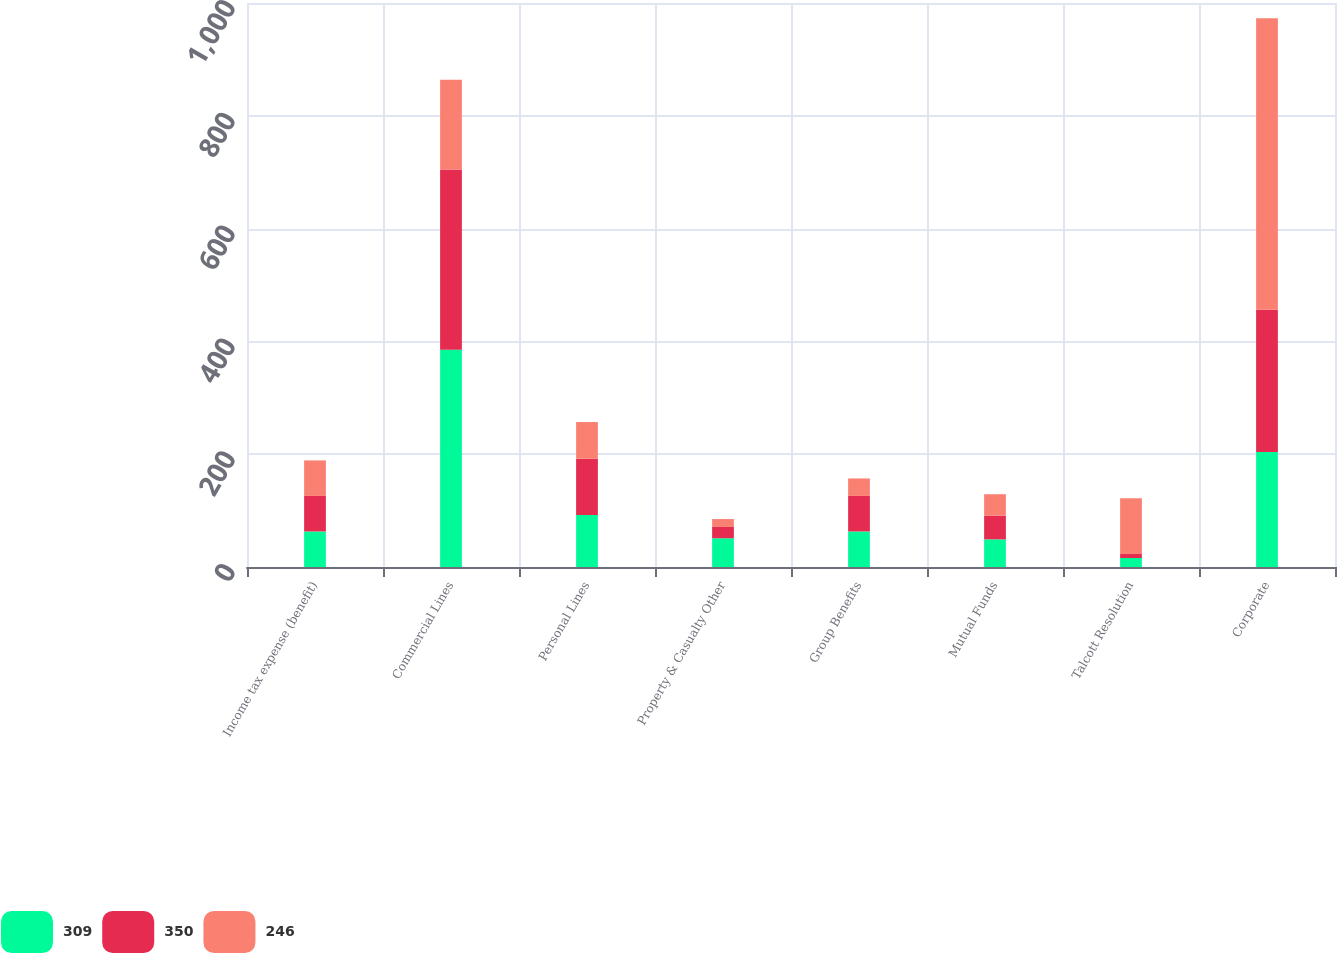Convert chart. <chart><loc_0><loc_0><loc_500><loc_500><stacked_bar_chart><ecel><fcel>Income tax expense (benefit)<fcel>Commercial Lines<fcel>Personal Lines<fcel>Property & Casualty Other<fcel>Group Benefits<fcel>Mutual Funds<fcel>Talcott Resolution<fcel>Corporate<nl><fcel>309<fcel>63<fcel>385<fcel>92<fcel>51<fcel>63<fcel>49<fcel>16<fcel>204<nl><fcel>350<fcel>63<fcel>320<fcel>100<fcel>20<fcel>63<fcel>42<fcel>7<fcel>252<nl><fcel>246<fcel>63<fcel>159<fcel>65<fcel>14<fcel>31<fcel>38<fcel>99<fcel>517<nl></chart> 